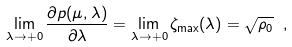<formula> <loc_0><loc_0><loc_500><loc_500>\lim _ { \lambda \to + 0 } \frac { \partial p ( \mu , \lambda ) } { \partial \lambda } = \lim _ { \lambda \to + 0 } \zeta _ { \max } ( \lambda ) = \sqrt { \rho _ { 0 } } \ ,</formula> 